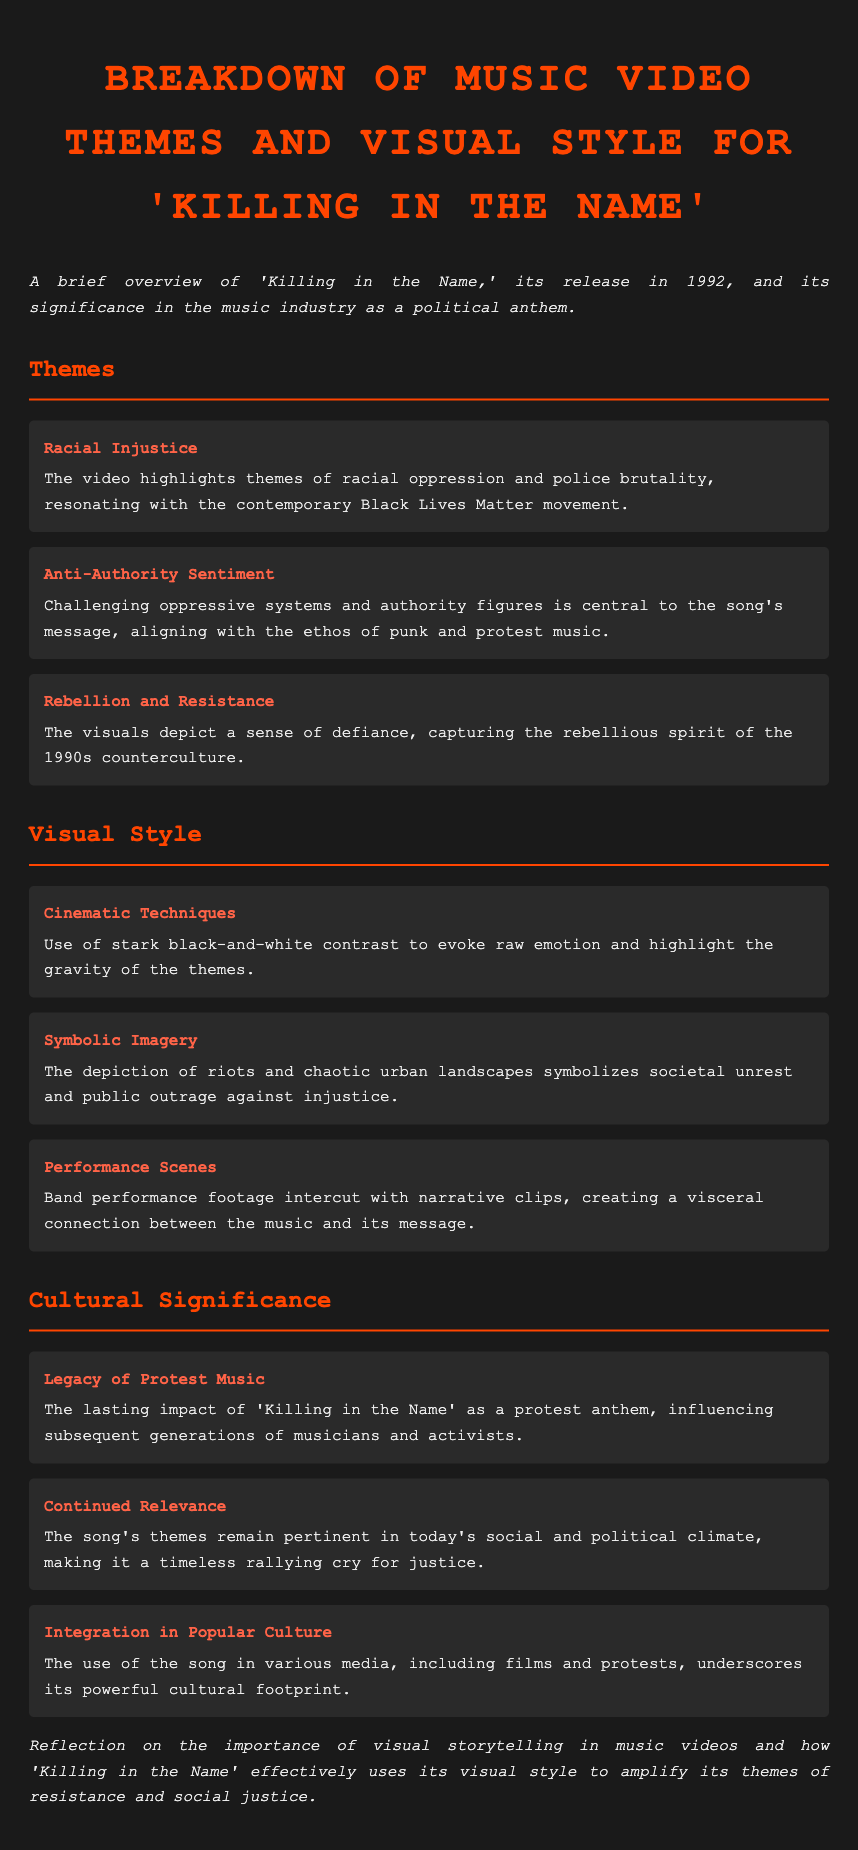What year was 'Killing in the Name' released? The document states that 'Killing in the Name' was released in 1992.
Answer: 1992 What theme highlights racial oppression and police brutality? The theme that addresses racial oppression and police brutality is explicitly mentioned as "Racial Injustice."
Answer: Racial Injustice What cinematic technique is used to evoke raw emotion? The document mentions "stark black-and-white contrast" as a cinematic technique used in the video.
Answer: stark black-and-white contrast What is a key aspect of the song’s cultural significance? The document describes a key aspect of the song's cultural significance as its "Legacy of Protest Music."
Answer: Legacy of Protest Music How many main themes are discussed in the document? The document lists three main themes under the section Themes.
Answer: three What type of imagery depicts societal unrest? The document identifies "Symbolic Imagery" as the type of imagery that symbolizes societal unrest.
Answer: Symbolic Imagery What ongoing movement does the song resonate with? The document mentions that the themes resonate with the contemporary "Black Lives Matter movement."
Answer: Black Lives Matter movement What is intercut with performance scenes in the music video? The document states that "narrative clips" are intercut with the band performance footage.
Answer: narrative clips What is the underlying message of the song and video? The document reflects that the video effectively uses its visual style to amplify themes of "resistance and social justice."
Answer: resistance and social justice 